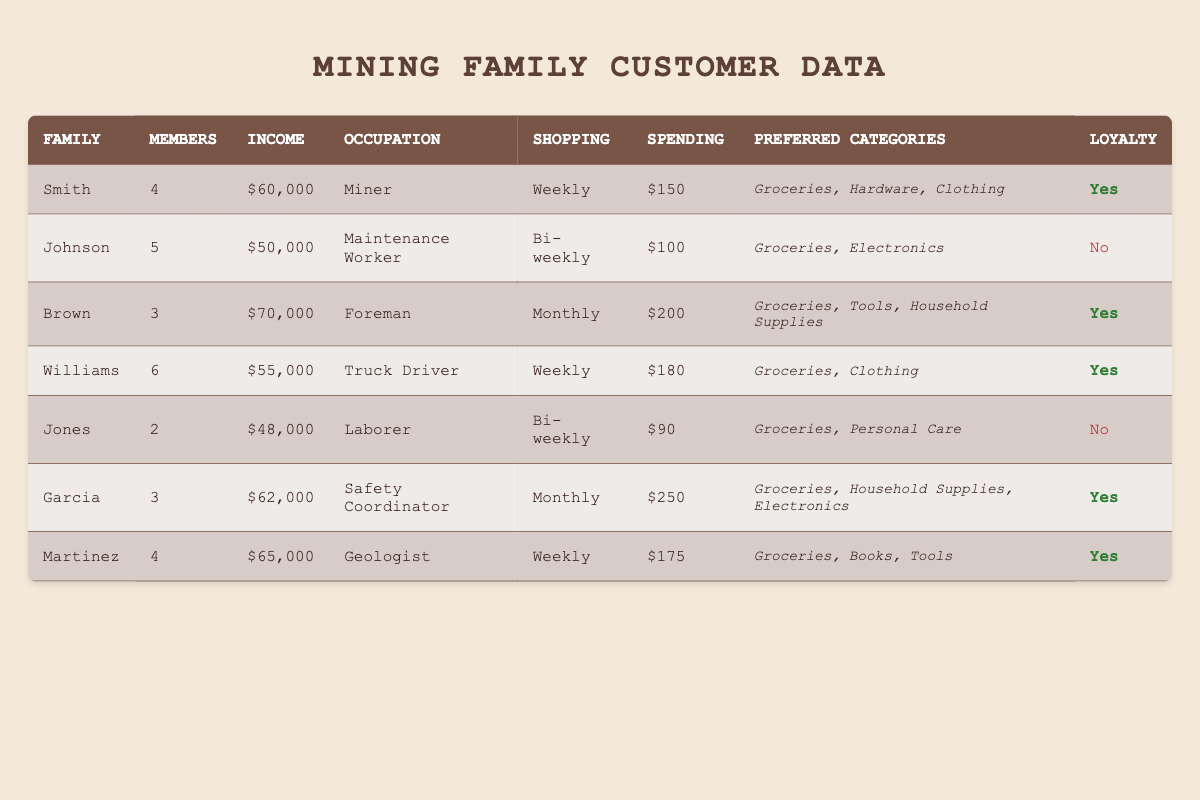What is the total income of all families listed? To find the total income, we sum the income of each family: 60000 + 50000 + 70000 + 55000 + 48000 + 62000 + 65000 = 410000
Answer: 410000 How many families are part of the loyalty program? From the table, the families who are loyalty program members are Smith, Brown, Williams, Garcia, and Martinez. That's a total of 5 families.
Answer: 5 Which family has the highest typical spending? Looking at the "typical spending" column, Garcia has the highest at $250.
Answer: Garcia What is the average shopping frequency of the families? There are seven families with varying shopping frequencies: Weekly (4), Bi-weekly (2), Monthly (1). To calculate an approximate average, we'll give Weekly a value of 1, Bi-weekly a value of 2, and Monthly a value of 3: (4*1 + 2*2 + 1*3) / 7 = (4 + 4 + 3) / 7 = 11 / 7 ≈ 1.57, which could be approximately 1.57 weeks.
Answer: Approximately 1.57 weeks Is there a family with a primary occupation as a Geologist? Yes, there is one family listed with a primary occupation as a Geologist, which is the Martinez family.
Answer: Yes What is the typical spending of families who shop weekly? The typical spendings of families who shop weekly are Smith ($150), Williams ($180), and Martinez ($175). Adding them up: 150 + 180 + 175 = 505. Average is 505 / 3 = 168.33.
Answer: 168.33 Which family has the most members? The family with the most members is Williams with 6 members.
Answer: Williams Do all families who spend more than $150 typical spending belong to the loyalty program? To assess this, we check the typical spending: Brown ($200), Garcia ($250), and compare if they are loyalty members. Brown and Garcia are indeed loyalty members, hence all families with spending over $150 belong to the program.
Answer: Yes What percentage of families shop bi-weekly? There are 2 families that shop bi-weekly out of a total of 7 families. To find the percentage: (2 / 7) * 100 ≈ 28.57%.
Answer: Approximately 28.57% How many preferred shopping categories does the Smith family have? The Smith family has 3 preferred shopping categories: Groceries, Hardware, and Clothing.
Answer: 3 